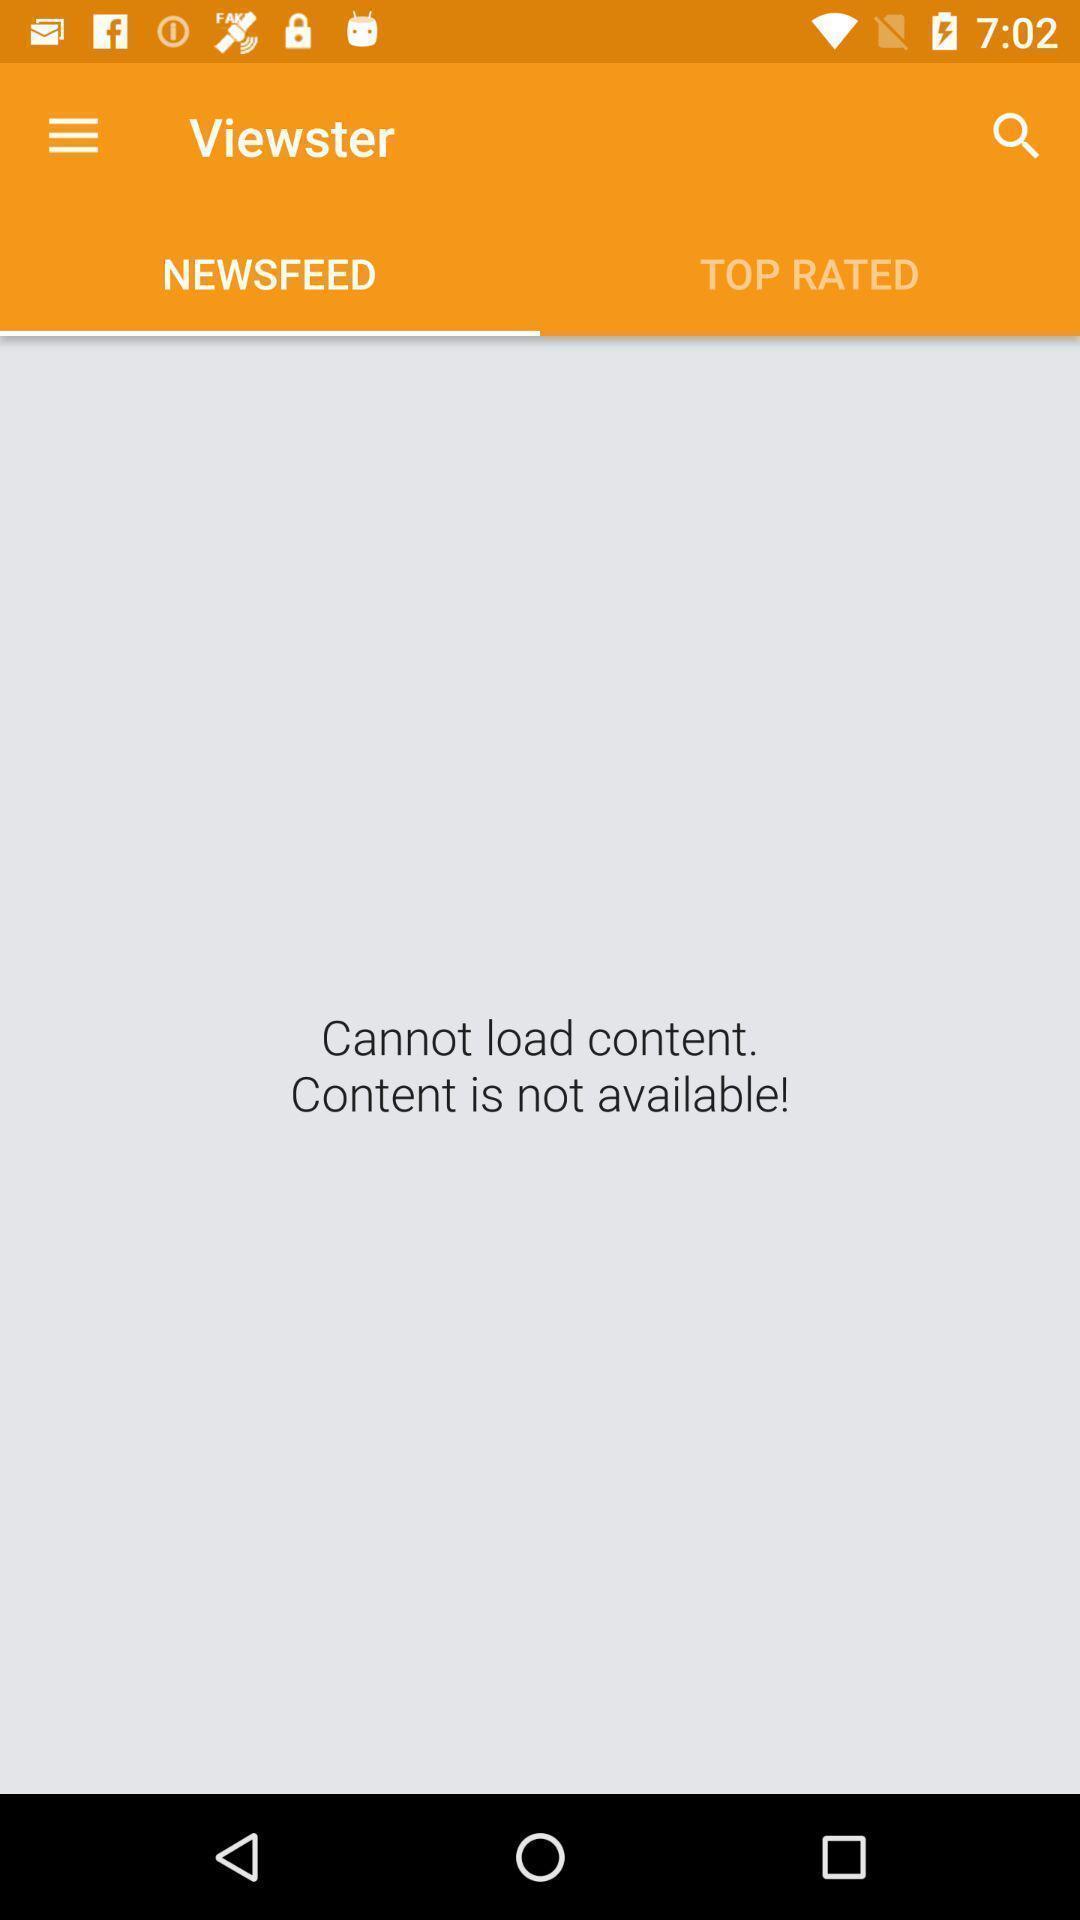Describe the content in this image. Page displaying no content available. 